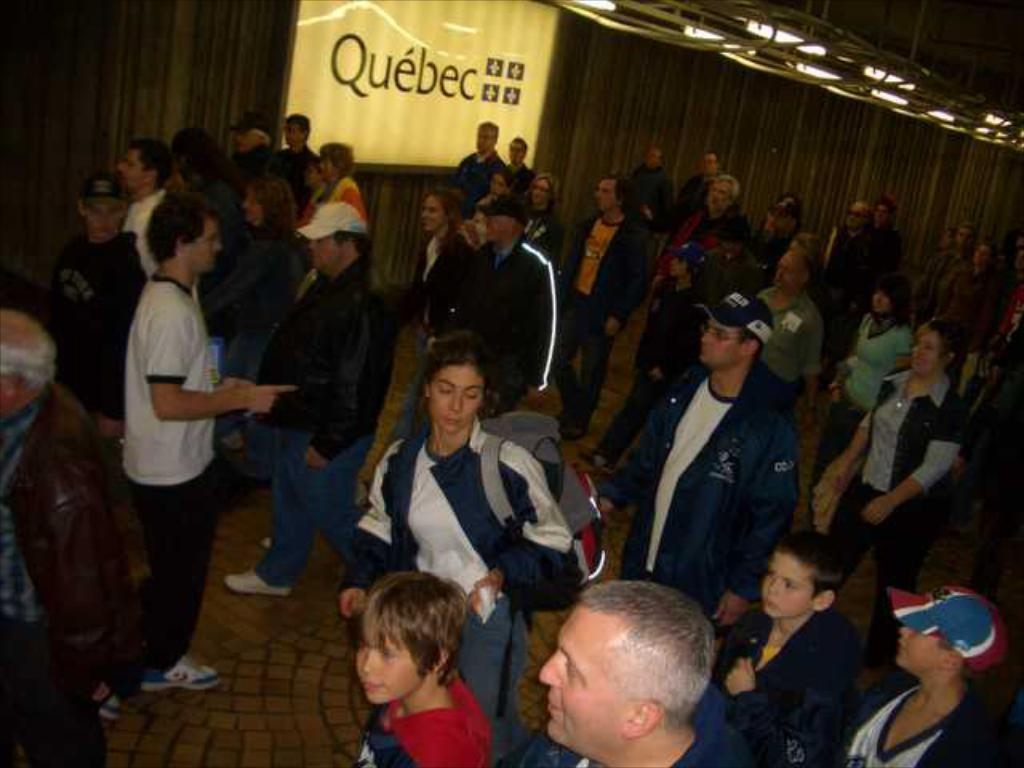How many people are in the image? There is a group of persons in the image. What are the persons in the image doing? The persons are walking. What can be seen in the background of the image? There is a banner on a wall in the background of the image. What is written on the banner? There is text written on the banner. Can you suggest a better route for the group of persons to take in the image? There is no information provided about the route or any alternative routes, so it is not possible to suggest a better route. 